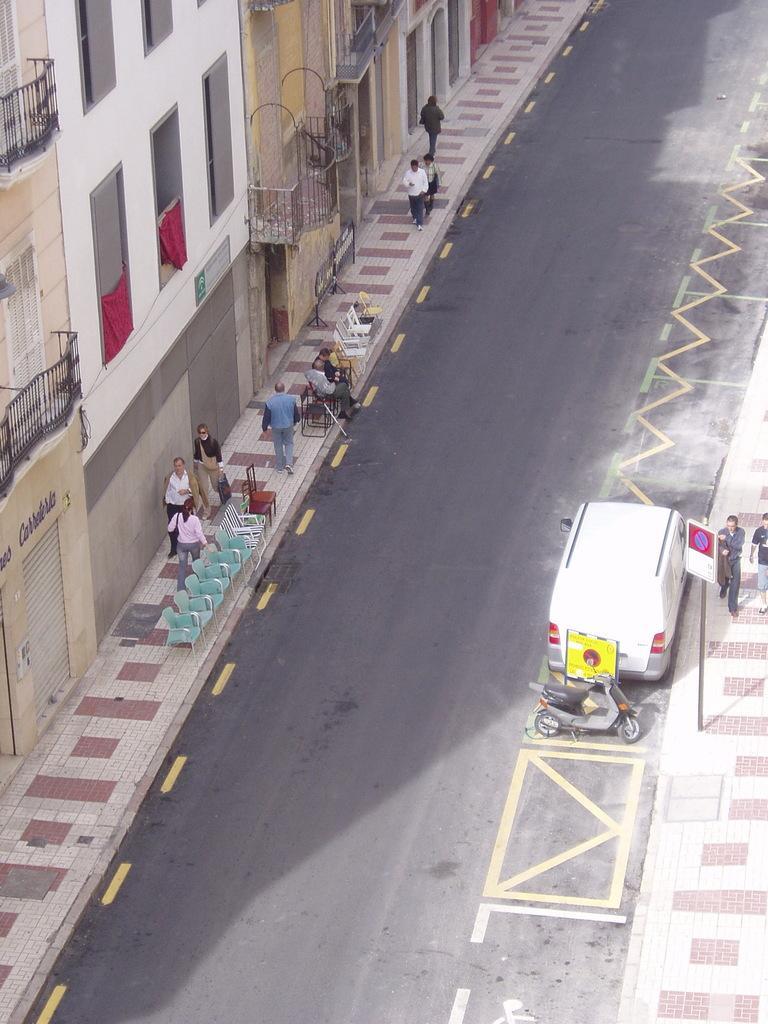Can you describe this image briefly? In this image there are vehicles on the road, board attached to the pole, group of people, chairs, buildings. 